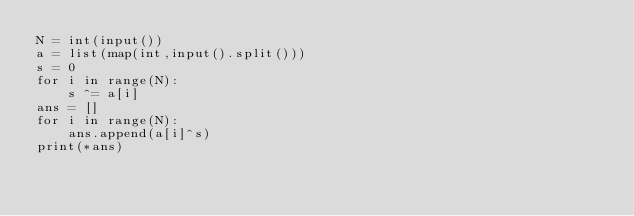<code> <loc_0><loc_0><loc_500><loc_500><_Python_>N = int(input())
a = list(map(int,input().split()))
s = 0
for i in range(N):
    s ^= a[i]
ans = []
for i in range(N):
    ans.append(a[i]^s)
print(*ans)</code> 